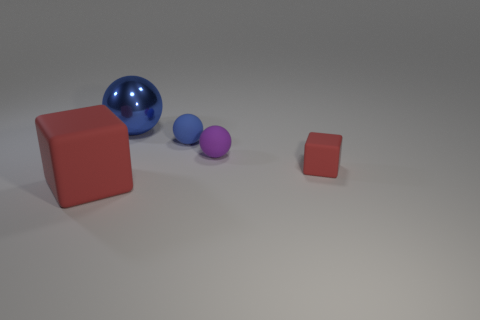Are there any other things that have the same material as the large blue ball?
Keep it short and to the point. No. Does the tiny cube have the same color as the large rubber thing?
Offer a very short reply. Yes. Are there any tiny purple things that have the same material as the tiny block?
Your response must be concise. Yes. Are there more small purple balls on the right side of the large blue metal sphere than rubber blocks that are behind the small red rubber block?
Provide a succinct answer. Yes. How big is the purple matte sphere?
Your response must be concise. Small. There is a matte thing that is on the left side of the small blue matte sphere; what shape is it?
Offer a very short reply. Cube. Is the big rubber object the same shape as the small red thing?
Your response must be concise. Yes. Are there an equal number of big blue metallic objects on the right side of the tiny red object and gray cubes?
Keep it short and to the point. Yes. What is the shape of the big red matte object?
Offer a very short reply. Cube. There is a matte cube that is to the left of the big blue sphere; does it have the same size as the red rubber object to the right of the blue matte sphere?
Your response must be concise. No. 